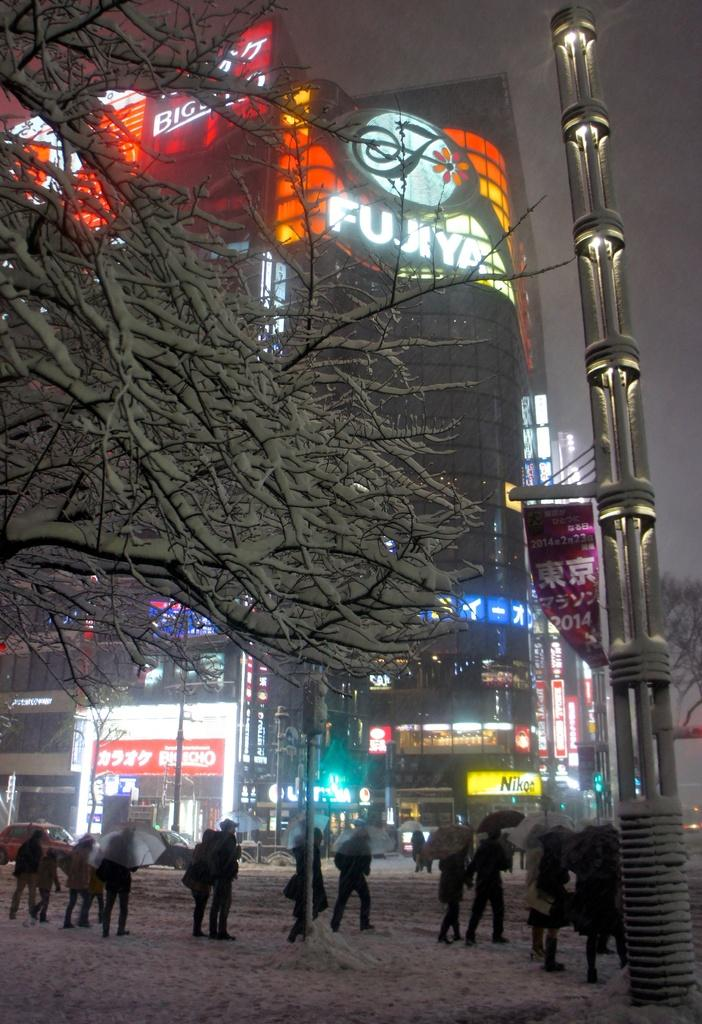What are the persons in the image doing? The persons in the image are standing on the road. What are the persons holding in the image? The persons are holding umbrellas. What is the weather like in the image? There is snow visible in the image, indicating a cold and likely snowy weather. What type of vegetation can be seen in the image? There are trees in the image. What structures are visible in the image? There is a tower and buildings in the image. What is visible in the sky in the image? The sky is visible in the image. What type of birthday celebration is taking place in the image? There is no indication of a birthday celebration in the image. What tool is being used to fix the wrench in the image? There is no wrench or tool usage depicted in the image. 